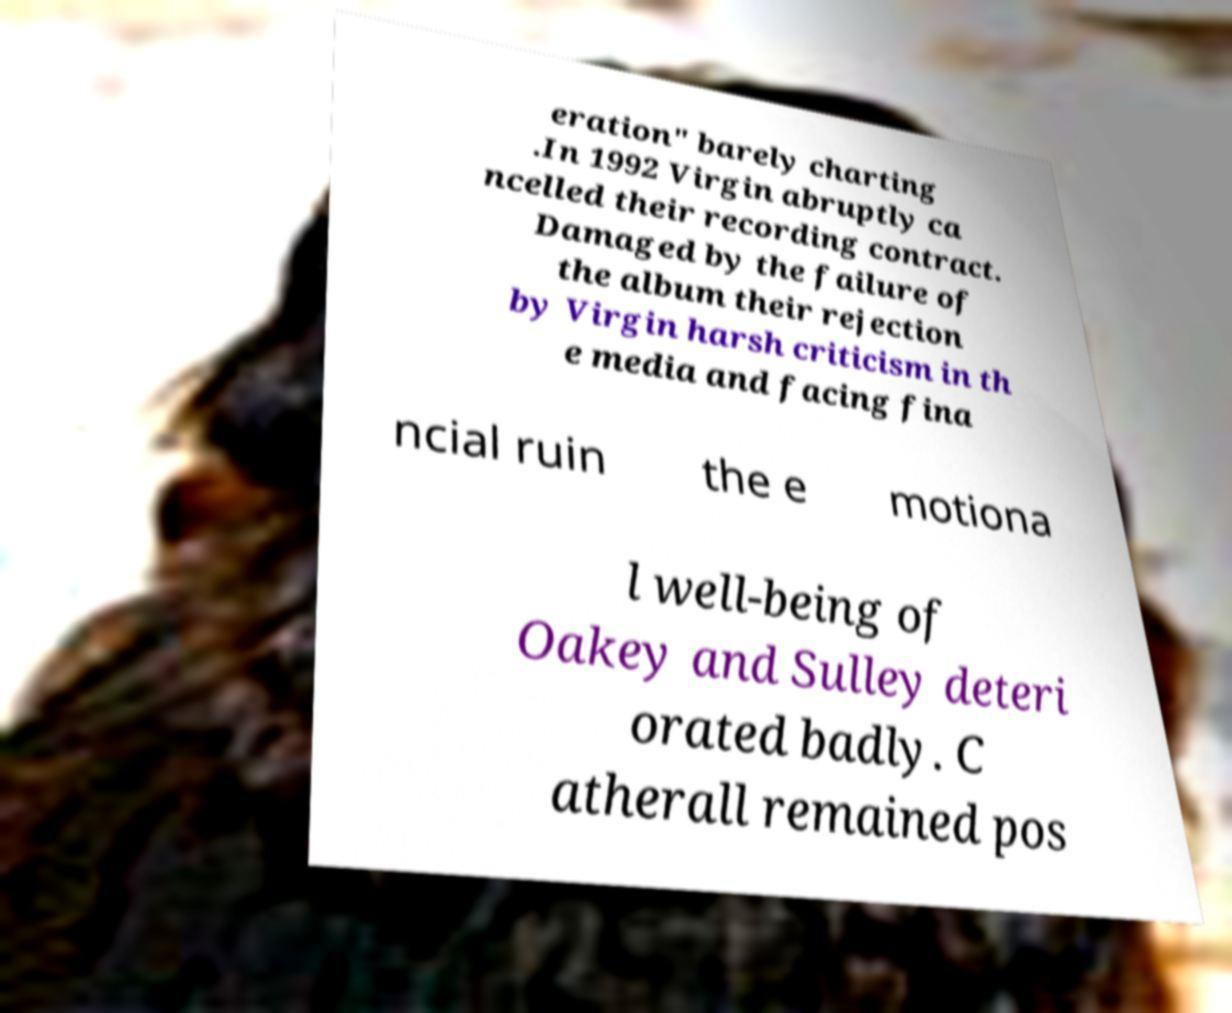For documentation purposes, I need the text within this image transcribed. Could you provide that? eration" barely charting .In 1992 Virgin abruptly ca ncelled their recording contract. Damaged by the failure of the album their rejection by Virgin harsh criticism in th e media and facing fina ncial ruin the e motiona l well-being of Oakey and Sulley deteri orated badly. C atherall remained pos 